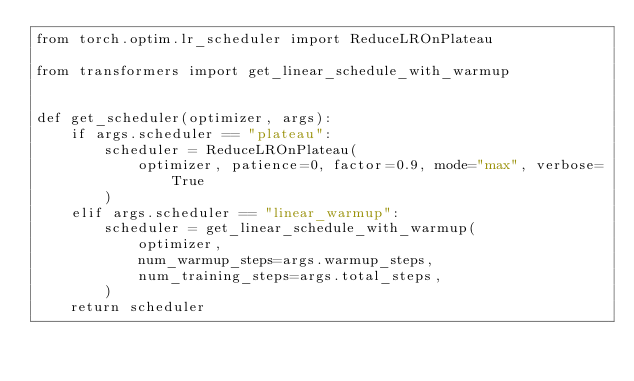Convert code to text. <code><loc_0><loc_0><loc_500><loc_500><_Python_>from torch.optim.lr_scheduler import ReduceLROnPlateau

from transformers import get_linear_schedule_with_warmup


def get_scheduler(optimizer, args):
    if args.scheduler == "plateau":
        scheduler = ReduceLROnPlateau(
            optimizer, patience=0, factor=0.9, mode="max", verbose=True
        )
    elif args.scheduler == "linear_warmup":
        scheduler = get_linear_schedule_with_warmup(
            optimizer,
            num_warmup_steps=args.warmup_steps,
            num_training_steps=args.total_steps,
        )
    return scheduler
</code> 